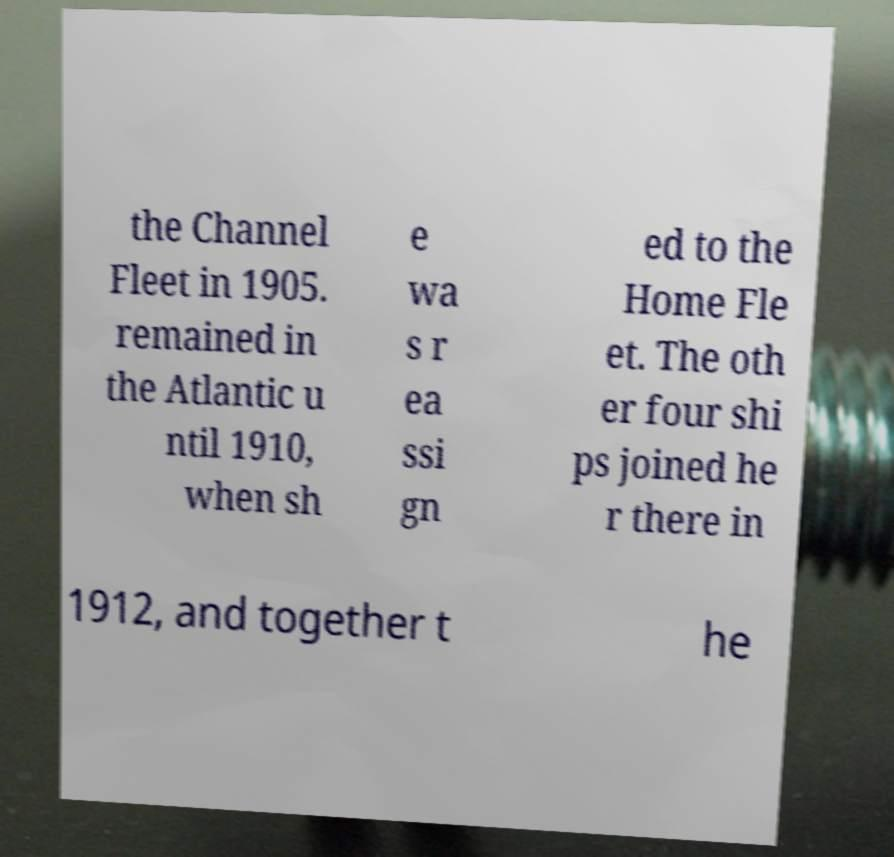Could you assist in decoding the text presented in this image and type it out clearly? the Channel Fleet in 1905. remained in the Atlantic u ntil 1910, when sh e wa s r ea ssi gn ed to the Home Fle et. The oth er four shi ps joined he r there in 1912, and together t he 